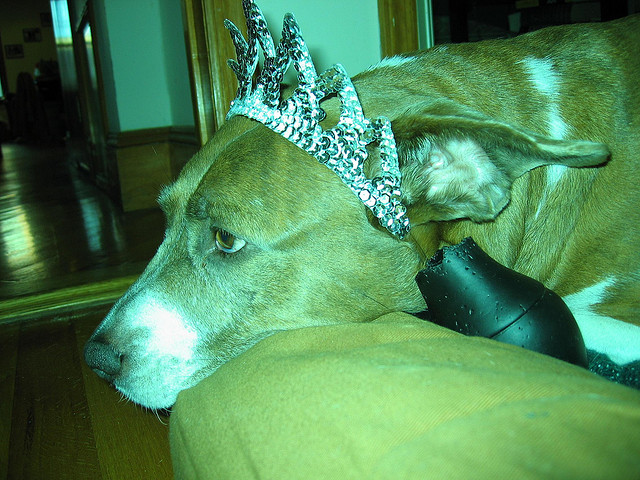<image>Why is the dog so sad? It is unknown why the dog is sad. However, it could be due to wearing a crown, feeling lonely, or having chewed up his toy. Why is the dog so sad? I don't know why the dog is so sad. It can be because it is lonely, dislikes wearing a crown or tiara, or maybe it chewed up its toy. 